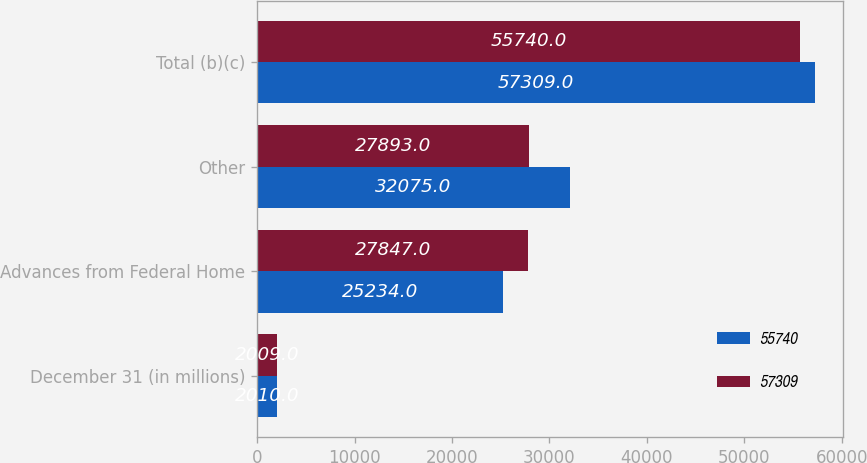Convert chart to OTSL. <chart><loc_0><loc_0><loc_500><loc_500><stacked_bar_chart><ecel><fcel>December 31 (in millions)<fcel>Advances from Federal Home<fcel>Other<fcel>Total (b)(c)<nl><fcel>55740<fcel>2010<fcel>25234<fcel>32075<fcel>57309<nl><fcel>57309<fcel>2009<fcel>27847<fcel>27893<fcel>55740<nl></chart> 